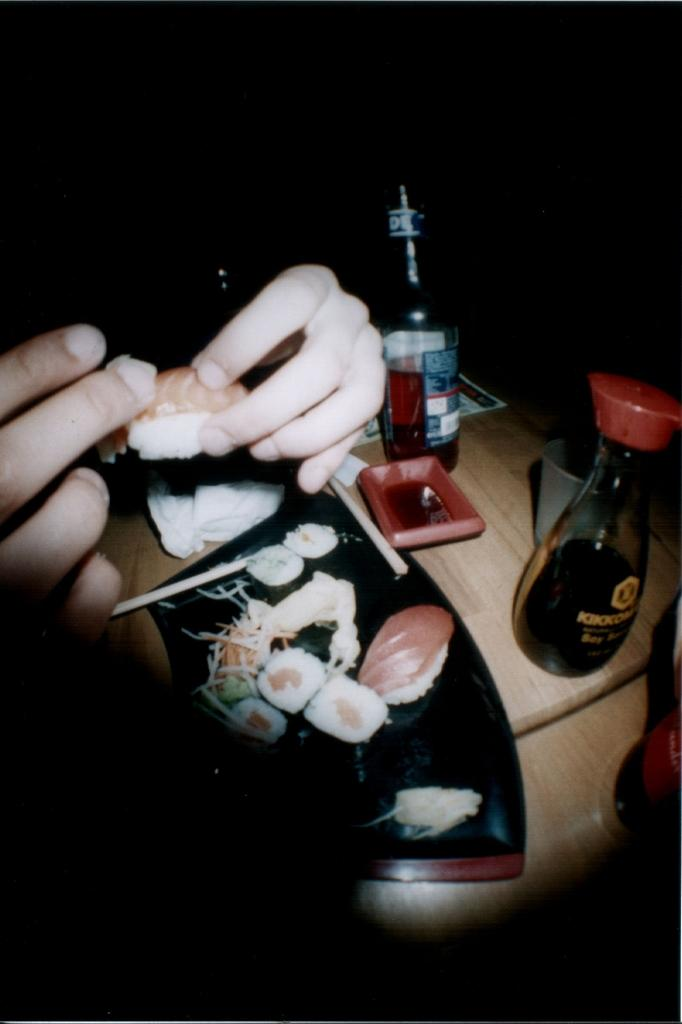What type of furniture is present in the image? There is a table in the image. What type of food can be seen on the table? There are nachos, buns, salads, and jars in the image. What type of beverages are present in the image? There are wine bottles and glasses in the image. Can you describe the person in the image? There is a person on the left side of the image, and they are holding a bun. What type of balls can be seen in the image? There are no balls present in the image. What time is it according to the watch in the image? There is no watch present in the image. 